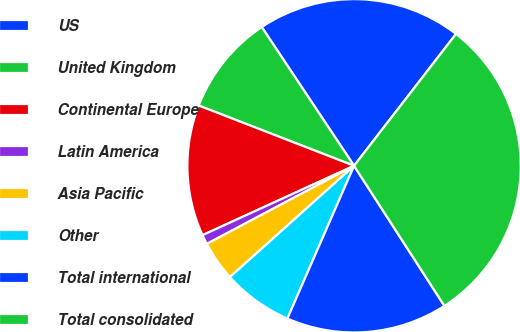Convert chart to OTSL. <chart><loc_0><loc_0><loc_500><loc_500><pie_chart><fcel>US<fcel>United Kingdom<fcel>Continental Europe<fcel>Latin America<fcel>Asia Pacific<fcel>Other<fcel>Total international<fcel>Total consolidated<nl><fcel>19.82%<fcel>9.77%<fcel>12.72%<fcel>0.93%<fcel>3.87%<fcel>6.82%<fcel>15.67%<fcel>30.41%<nl></chart> 